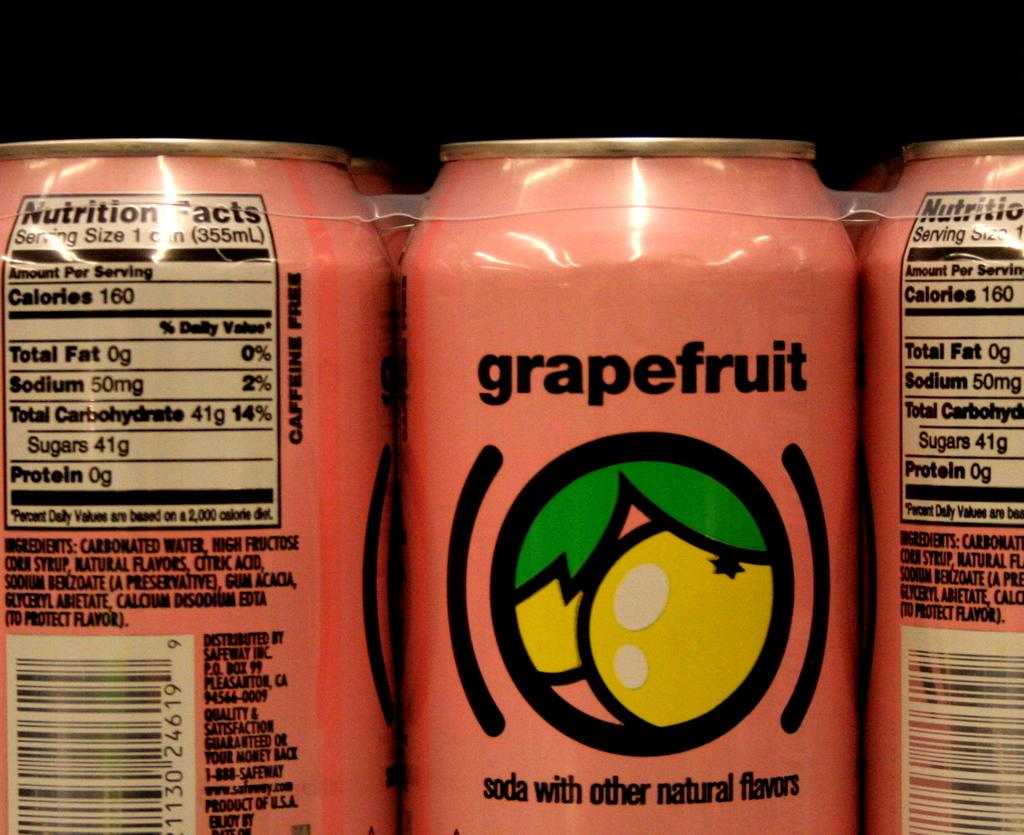Provide a one-sentence caption for the provided image. A pink can containing grapefruit soda sits bound to other cans waiting to be sold. 